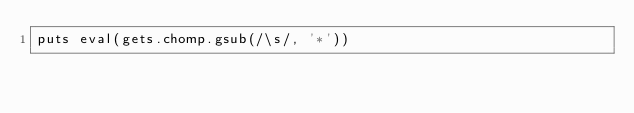Convert code to text. <code><loc_0><loc_0><loc_500><loc_500><_Ruby_>puts eval(gets.chomp.gsub(/\s/, '*'))
</code> 